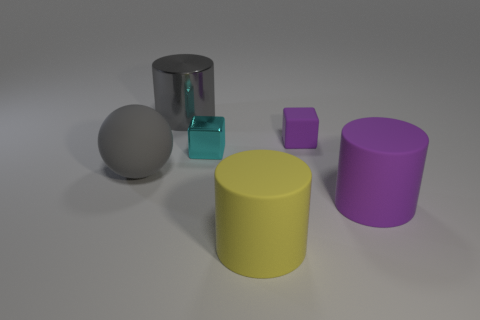Subtract 1 cylinders. How many cylinders are left? 2 Add 3 big yellow cylinders. How many objects exist? 9 Subtract all spheres. How many objects are left? 5 Add 1 red metallic things. How many red metallic things exist? 1 Subtract 0 brown cylinders. How many objects are left? 6 Subtract all purple rubber cylinders. Subtract all gray shiny objects. How many objects are left? 4 Add 3 blocks. How many blocks are left? 5 